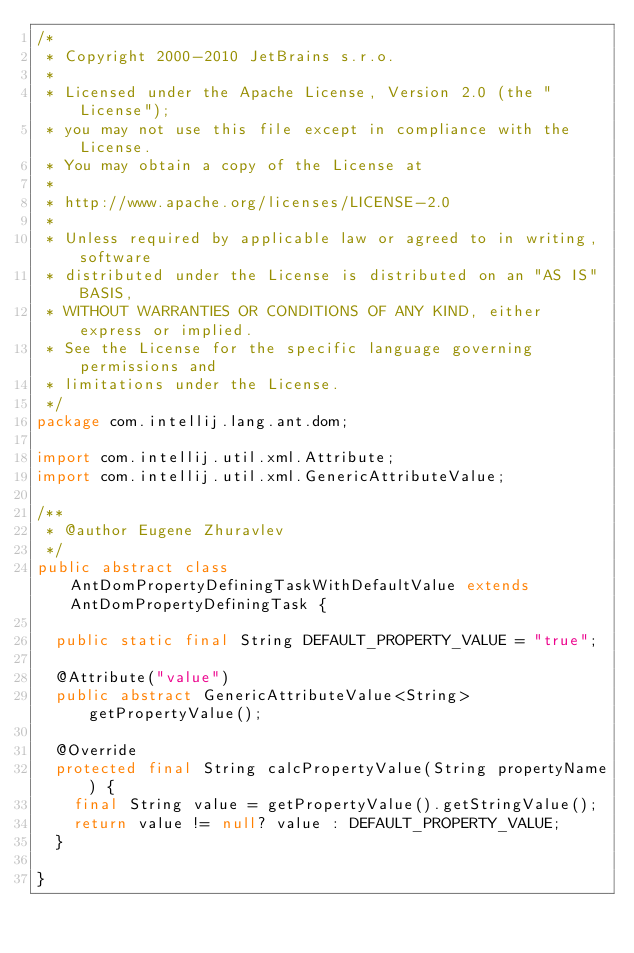<code> <loc_0><loc_0><loc_500><loc_500><_Java_>/*
 * Copyright 2000-2010 JetBrains s.r.o.
 *
 * Licensed under the Apache License, Version 2.0 (the "License");
 * you may not use this file except in compliance with the License.
 * You may obtain a copy of the License at
 *
 * http://www.apache.org/licenses/LICENSE-2.0
 *
 * Unless required by applicable law or agreed to in writing, software
 * distributed under the License is distributed on an "AS IS" BASIS,
 * WITHOUT WARRANTIES OR CONDITIONS OF ANY KIND, either express or implied.
 * See the License for the specific language governing permissions and
 * limitations under the License.
 */
package com.intellij.lang.ant.dom;

import com.intellij.util.xml.Attribute;
import com.intellij.util.xml.GenericAttributeValue;

/**
 * @author Eugene Zhuravlev
 */
public abstract class AntDomPropertyDefiningTaskWithDefaultValue extends AntDomPropertyDefiningTask {

  public static final String DEFAULT_PROPERTY_VALUE = "true";

  @Attribute("value")
  public abstract GenericAttributeValue<String> getPropertyValue();

  @Override
  protected final String calcPropertyValue(String propertyName) {
    final String value = getPropertyValue().getStringValue();
    return value != null? value : DEFAULT_PROPERTY_VALUE;
  }

}
</code> 